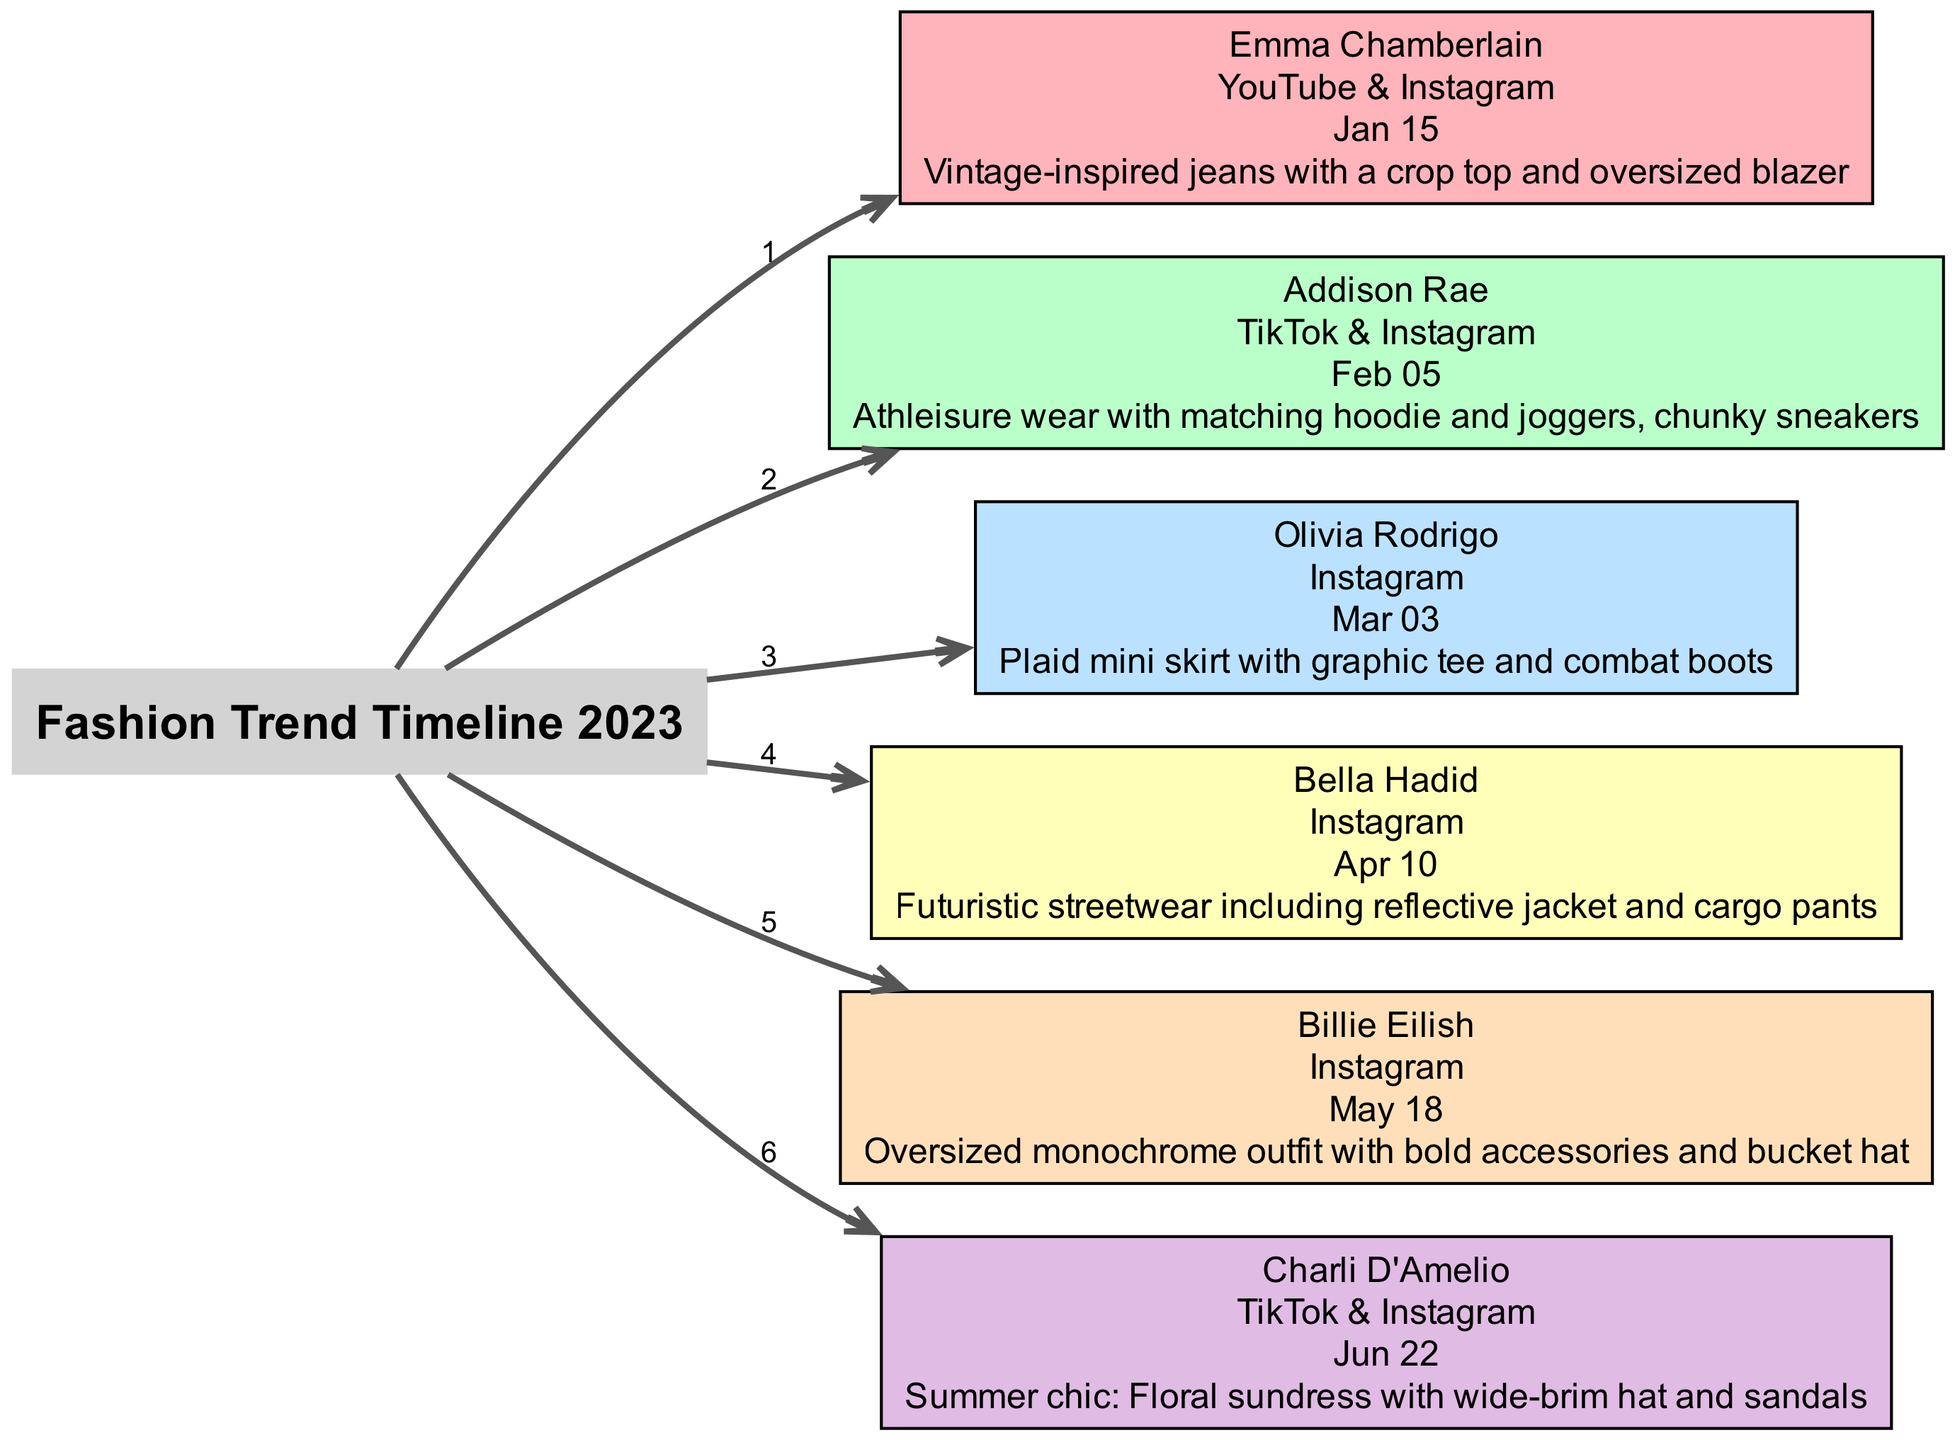What is the name of the influencer who posted on February 5, 2023? The diagram shows the timeline and lists the influencers with their respective post dates. By locating the node associated with February 5, 2023, we see that it is "Addison Rae."
Answer: Addison Rae What outfit did Emma Chamberlain post? The diagram provides a detailed description for each influencer's outfits. For Emma Chamberlain, the description is "Vintage-inspired jeans with a crop top and oversized blazer."
Answer: Vintage-inspired jeans with a crop top and oversized blazer How many influencers are listed in the diagram? The number of influencers is determined by counting the nodes in the diagram that represent each influencer. Upon counting, there are six influencers shown.
Answer: 6 Which platform did Olivia Rodrigo use to share her outfit? By checking the node for Olivia Rodrigo in the diagram, we see that the platform listed is "Instagram."
Answer: Instagram What color represents Billie Eilish in the diagram? Each influencer's node is assigned a specific color. To find Billie Eilish's corresponding color, we examine her node and find that it is "Oversized monochrome outfit with bold accessories and bucket hat" represented by a unique color. The color associated with her node is "#FFDFBA."
Answer: #FFDFBA Which influencer posted the first outfit, and what was the outfit? To determine the first post, we look for the earliest date in the timeline. The first date is January 15, 2023, associated with Emma Chamberlain's outfit, which is described in her node.
Answer: Emma Chamberlain, Vintage-inspired jeans with a crop top and oversized blazer What trend was showcased by Charli D'Amelio? The diagram includes a description of the outfit that Charli D'Amelio posted. By reviewing her node, we find that the trend described is "Summer chic: Floral sundress with wide-brim hat and sandals."
Answer: Summer chic: Floral sundress with wide-brim hat and sandals Which influencer was associated with futuristic streetwear? By scanning through the nodes for outfit descriptions, we identify Bella Hadid's node that describes "Futuristic streetwear including reflective jacket and cargo pants."
Answer: Bella Hadid What is the connection between the influencers and the timeline? The diagram connects each influencer to the central "Timeline" node through directed edges, indicating that each influencer represents a trend at a specific point in time within the broader timeline of 2023.
Answer: Direct edges indicate influence in time 